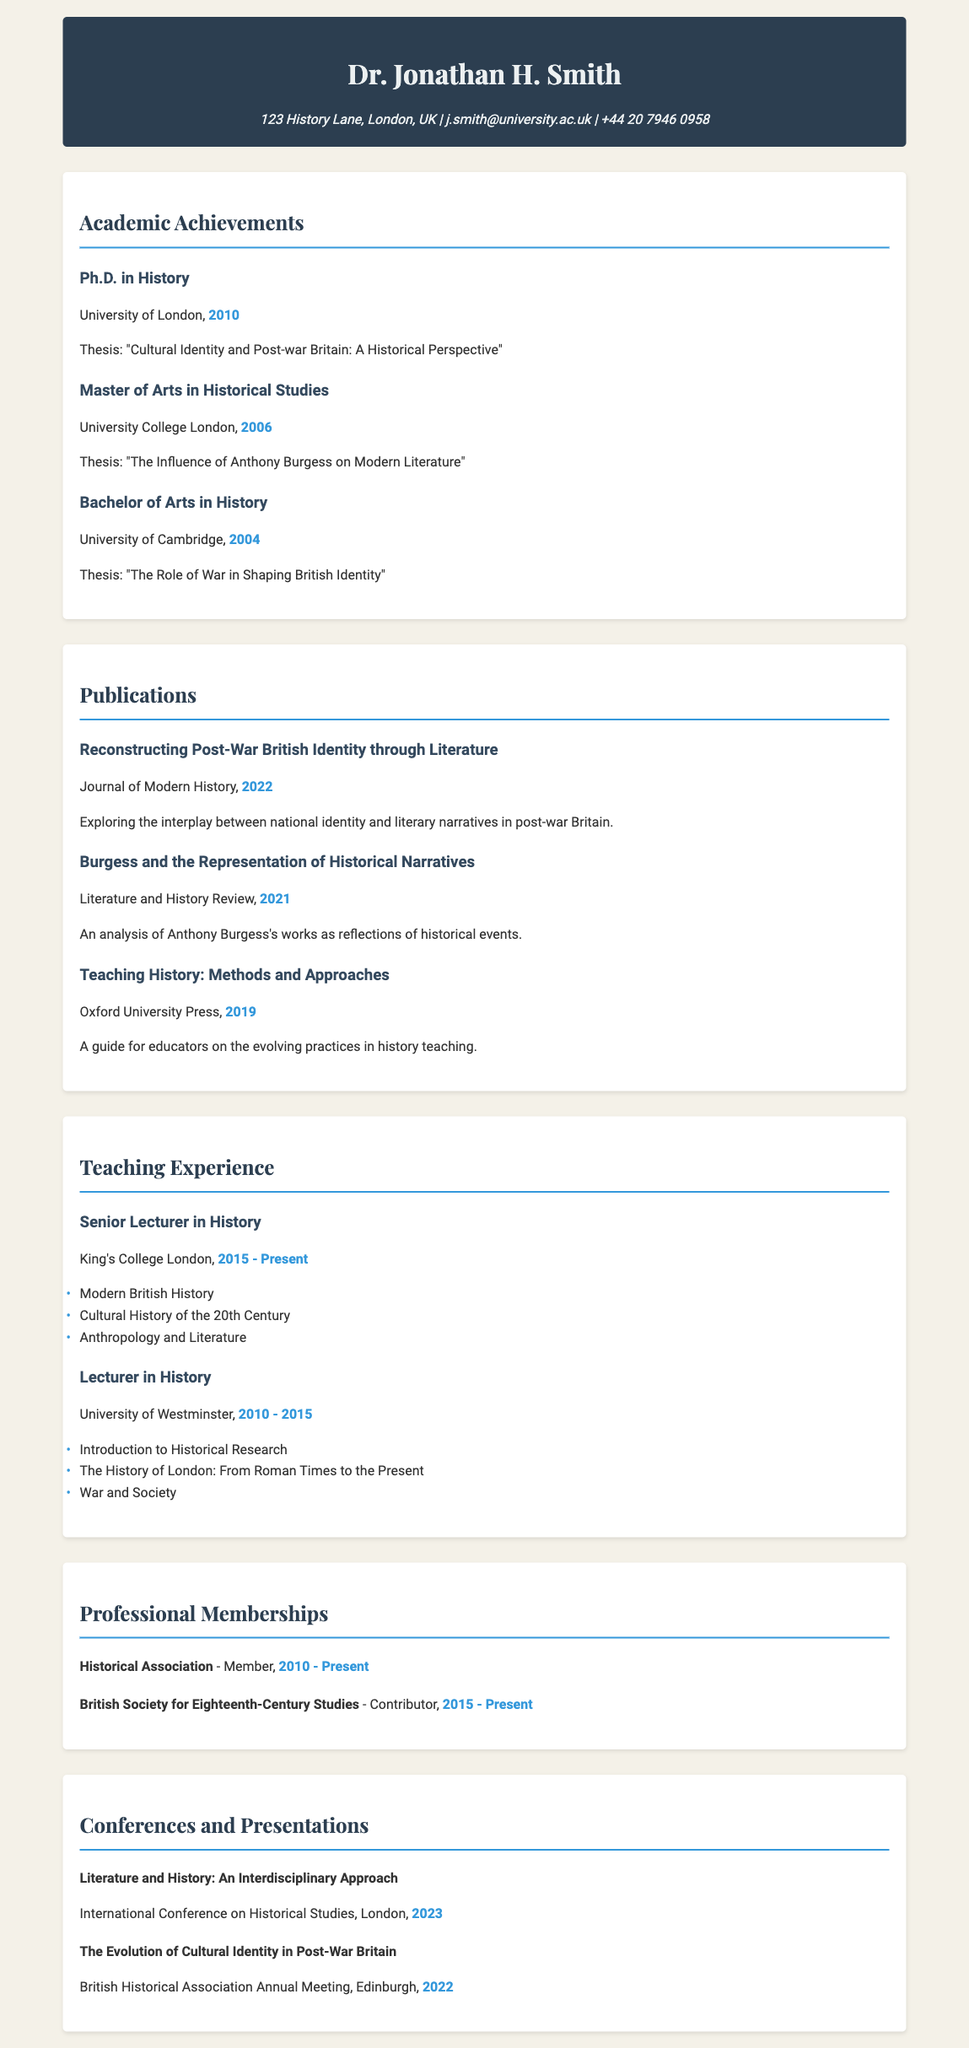What is the highest degree attained by Dr. Jonathan H. Smith? The highest degree is the Ph.D. in History, awarded in 2010.
Answer: Ph.D. in History In which year was the thesis about "The Influence of Anthony Burgess on Modern Literature" completed? The thesis was completed in 2006 as part of the Master's program.
Answer: 2006 Which university did Dr. Smith attend for his Bachelor's degree? The document states that he attended the University of Cambridge for his Bachelor's degree.
Answer: University of Cambridge How many publications are listed in the document? There are three publications mentioned in the Publications section.
Answer: Three What is the role held by Dr. Smith at King's College London? The document specifies that he is a Senior Lecturer in History at King's College London.
Answer: Senior Lecturer in History What is the title of Dr. Smith's publication from 2022? The title is "Reconstructing Post-War British Identity through Literature."
Answer: Reconstructing Post-War British Identity through Literature During which years did Dr. Smith serve as a Lecturer in History? The document indicates he served as a Lecturer from 2010 to 2015.
Answer: 2010 - 2015 Which professional membership has Dr. Smith held since 2010? He has been a member of the Historical Association since 2010.
Answer: Historical Association What is the theme of the conference presentation given in 2022? The theme is "The Evolution of Cultural Identity in Post-War Britain."
Answer: The Evolution of Cultural Identity in Post-War Britain 